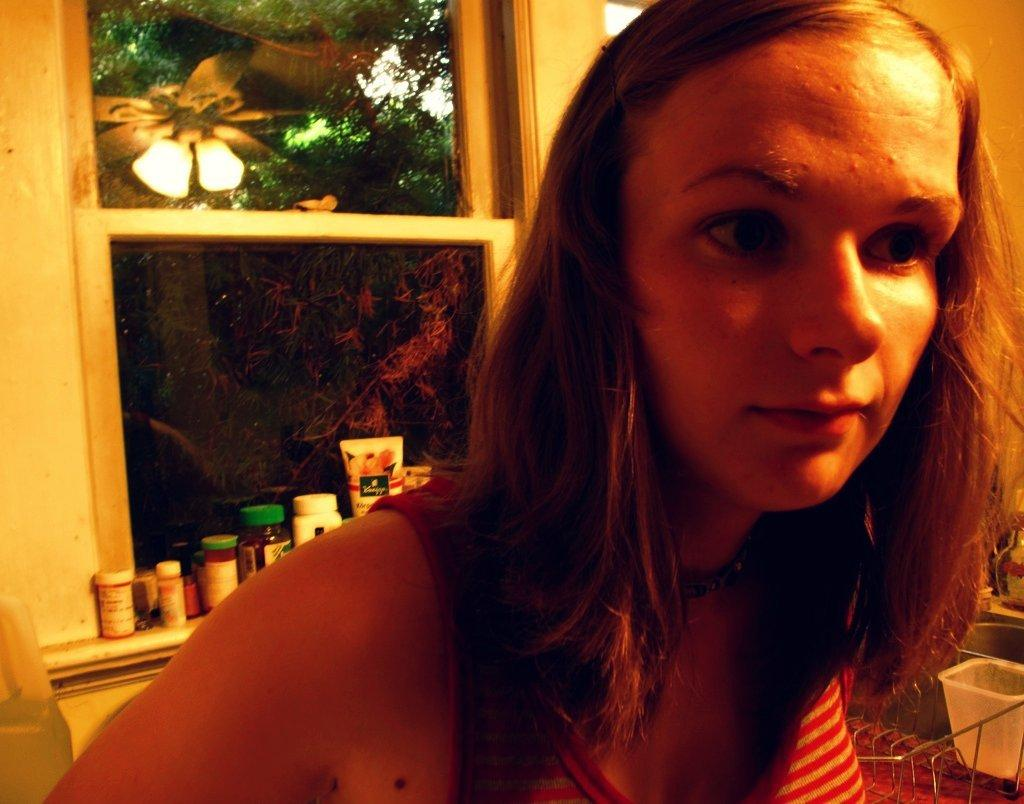What is present in the image? There is a person in the image. What can be seen in the background of the image? There are tubes and many jars on the window in the background. What objects are located to the right of the image? There are baskets to the right of the image. What is visible through the window in the background? Trees are visible through the window in the background. What time of day is it in the image, based on the hour? The provided facts do not mention the time of day or any hour, so it cannot be determined from the image. 